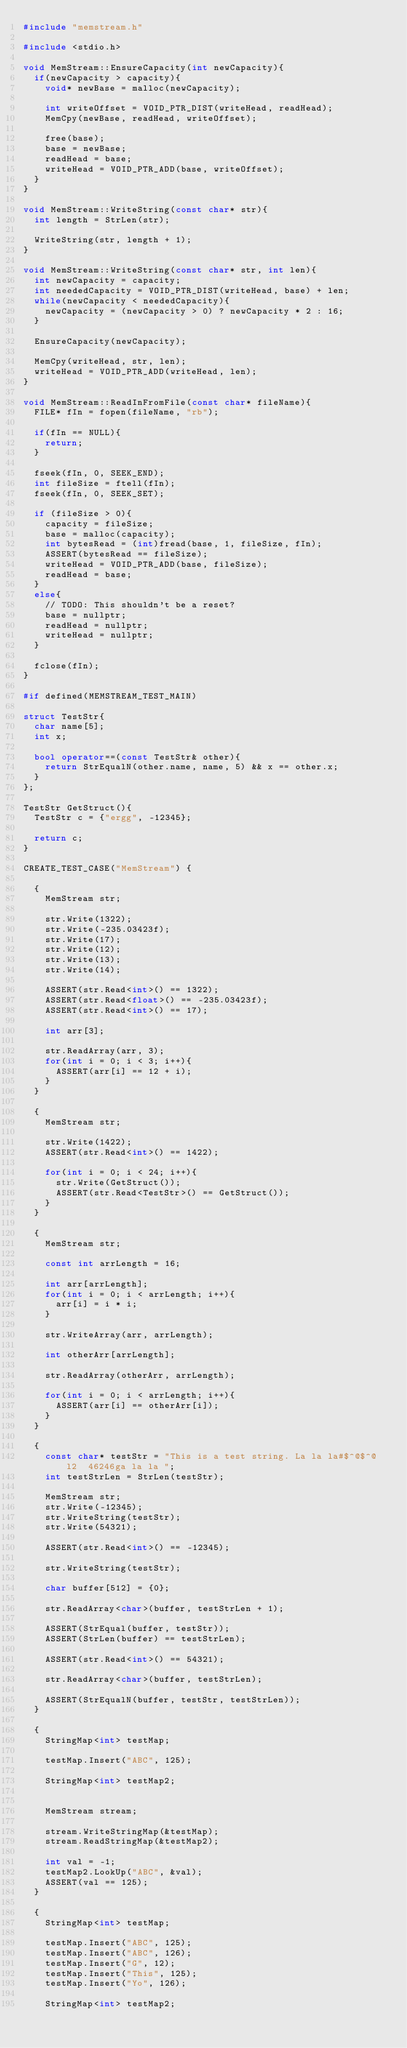<code> <loc_0><loc_0><loc_500><loc_500><_C++_>#include "memstream.h"

#include <stdio.h>

void MemStream::EnsureCapacity(int newCapacity){
	if(newCapacity > capacity){
		void* newBase = malloc(newCapacity);
		
		int writeOffset = VOID_PTR_DIST(writeHead, readHead);
		MemCpy(newBase, readHead, writeOffset);
		
		free(base);
		base = newBase;
		readHead = base;
		writeHead = VOID_PTR_ADD(base, writeOffset);
	}
}

void MemStream::WriteString(const char* str){
	int length = StrLen(str);
	
	WriteString(str, length + 1);
}

void MemStream::WriteString(const char* str, int len){
	int newCapacity = capacity;
	int neededCapacity = VOID_PTR_DIST(writeHead, base) + len;
	while(newCapacity < neededCapacity){
		newCapacity = (newCapacity > 0) ? newCapacity * 2 : 16;
	}
	
	EnsureCapacity(newCapacity);
		
	MemCpy(writeHead, str, len);
	writeHead = VOID_PTR_ADD(writeHead, len);
}

void MemStream::ReadInFromFile(const char* fileName){
	FILE* fIn = fopen(fileName, "rb");
	
	if(fIn == NULL){
		return;
	}
	
	fseek(fIn, 0, SEEK_END);
	int fileSize = ftell(fIn);
	fseek(fIn, 0, SEEK_SET);
	
	if (fileSize > 0){
		capacity = fileSize;
		base = malloc(capacity);
		int bytesRead = (int)fread(base, 1, fileSize, fIn);
		ASSERT(bytesRead == fileSize);
		writeHead = VOID_PTR_ADD(base, fileSize);
		readHead = base;
	}
	else{
		// TODO: This shouldn't be a reset?
		base = nullptr;
		readHead = nullptr;
		writeHead = nullptr;
	}
	
	fclose(fIn);
}

#if defined(MEMSTREAM_TEST_MAIN)

struct TestStr{
	char name[5];
	int x;
	
	bool operator==(const TestStr& other){
		return StrEqualN(other.name, name, 5) && x == other.x;
	}
};

TestStr GetStruct(){
	TestStr c = {"ergg", -12345};
	
	return c;
}

CREATE_TEST_CASE("MemStream") {

	{
		MemStream str;
		
		str.Write(1322);
		str.Write(-235.03423f);
		str.Write(17);
		str.Write(12);
		str.Write(13);
		str.Write(14);
		
		ASSERT(str.Read<int>() == 1322);
		ASSERT(str.Read<float>() == -235.03423f);
		ASSERT(str.Read<int>() == 17);
		
		int arr[3];
		
		str.ReadArray(arr, 3);
		for(int i = 0; i < 3; i++){
			ASSERT(arr[i] == 12 + i);
		}
	}
	
	{
		MemStream str;
		
		str.Write(1422);
		ASSERT(str.Read<int>() == 1422);
		
		for(int i = 0; i < 24; i++){
			str.Write(GetStruct());
			ASSERT(str.Read<TestStr>() == GetStruct());
		}
	}
	
	{
		MemStream str;
		
		const int arrLength = 16;
		
		int arr[arrLength];
		for(int i = 0; i < arrLength; i++){
			arr[i] = i * i;
		}
		
		str.WriteArray(arr, arrLength);
		
		int otherArr[arrLength];
		
		str.ReadArray(otherArr, arrLength);
		
		for(int i = 0; i < arrLength; i++){
			ASSERT(arr[i] == otherArr[i]);
		}
	}
	
	{
		const char* testStr = "This is a test string. La la la#$^@$^@ l2  46246ga la la ";
		int testStrLen = StrLen(testStr);
		
		MemStream str;
		str.Write(-12345);
		str.WriteString(testStr);
		str.Write(54321);
		
		ASSERT(str.Read<int>() == -12345);
		
		str.WriteString(testStr);
		
		char buffer[512] = {0};
		
		str.ReadArray<char>(buffer, testStrLen + 1);
		
		ASSERT(StrEqual(buffer, testStr));
		ASSERT(StrLen(buffer) == testStrLen);
		
		ASSERT(str.Read<int>() == 54321);
		
		str.ReadArray<char>(buffer, testStrLen);
		
		ASSERT(StrEqualN(buffer, testStr, testStrLen));
	}
	
	{
		StringMap<int> testMap;
		
		testMap.Insert("ABC", 125);

		StringMap<int> testMap2;


		MemStream stream;

		stream.WriteStringMap(&testMap);
		stream.ReadStringMap(&testMap2);

		int val = -1;
		testMap2.LookUp("ABC", &val);
		ASSERT(val == 125);
	}

	{
		StringMap<int> testMap;

		testMap.Insert("ABC", 125);
		testMap.Insert("ABC", 126);
		testMap.Insert("G", 12);
		testMap.Insert("This", 125);
		testMap.Insert("Yo", 126);

		StringMap<int> testMap2;

</code> 